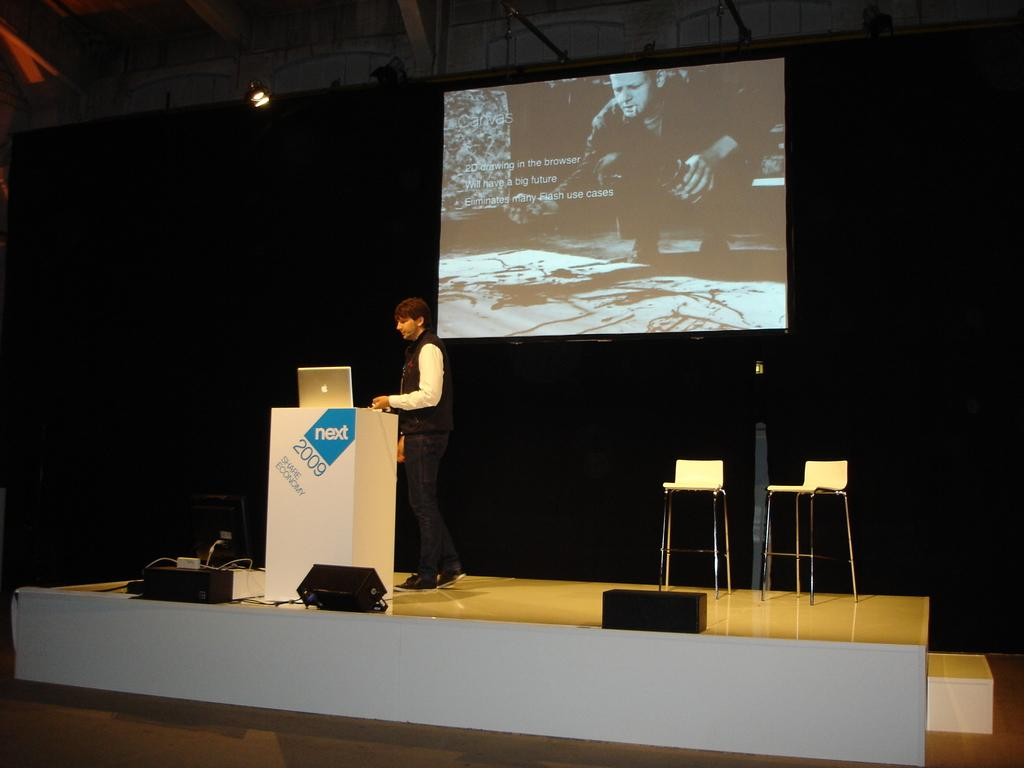What is the person in the image doing? The person is standing on the floor. What type of furniture can be seen in the image? There are chairs in the image. What electronic device is visible in the image? A laptop is visible in the image. What is the person likely to be using the laptop for? The presence of a podium, speakers, and a screen suggests that the person might be giving a presentation. What type of lighting is present in the image? Lights are visible in the image. What is the background of the image like? The background of the image is dark. What type of soda is being served to the friends in the image? There are no friends or soda present in the image. Can you tell me how many cameras are visible in the image? There are no cameras visible in the image. 